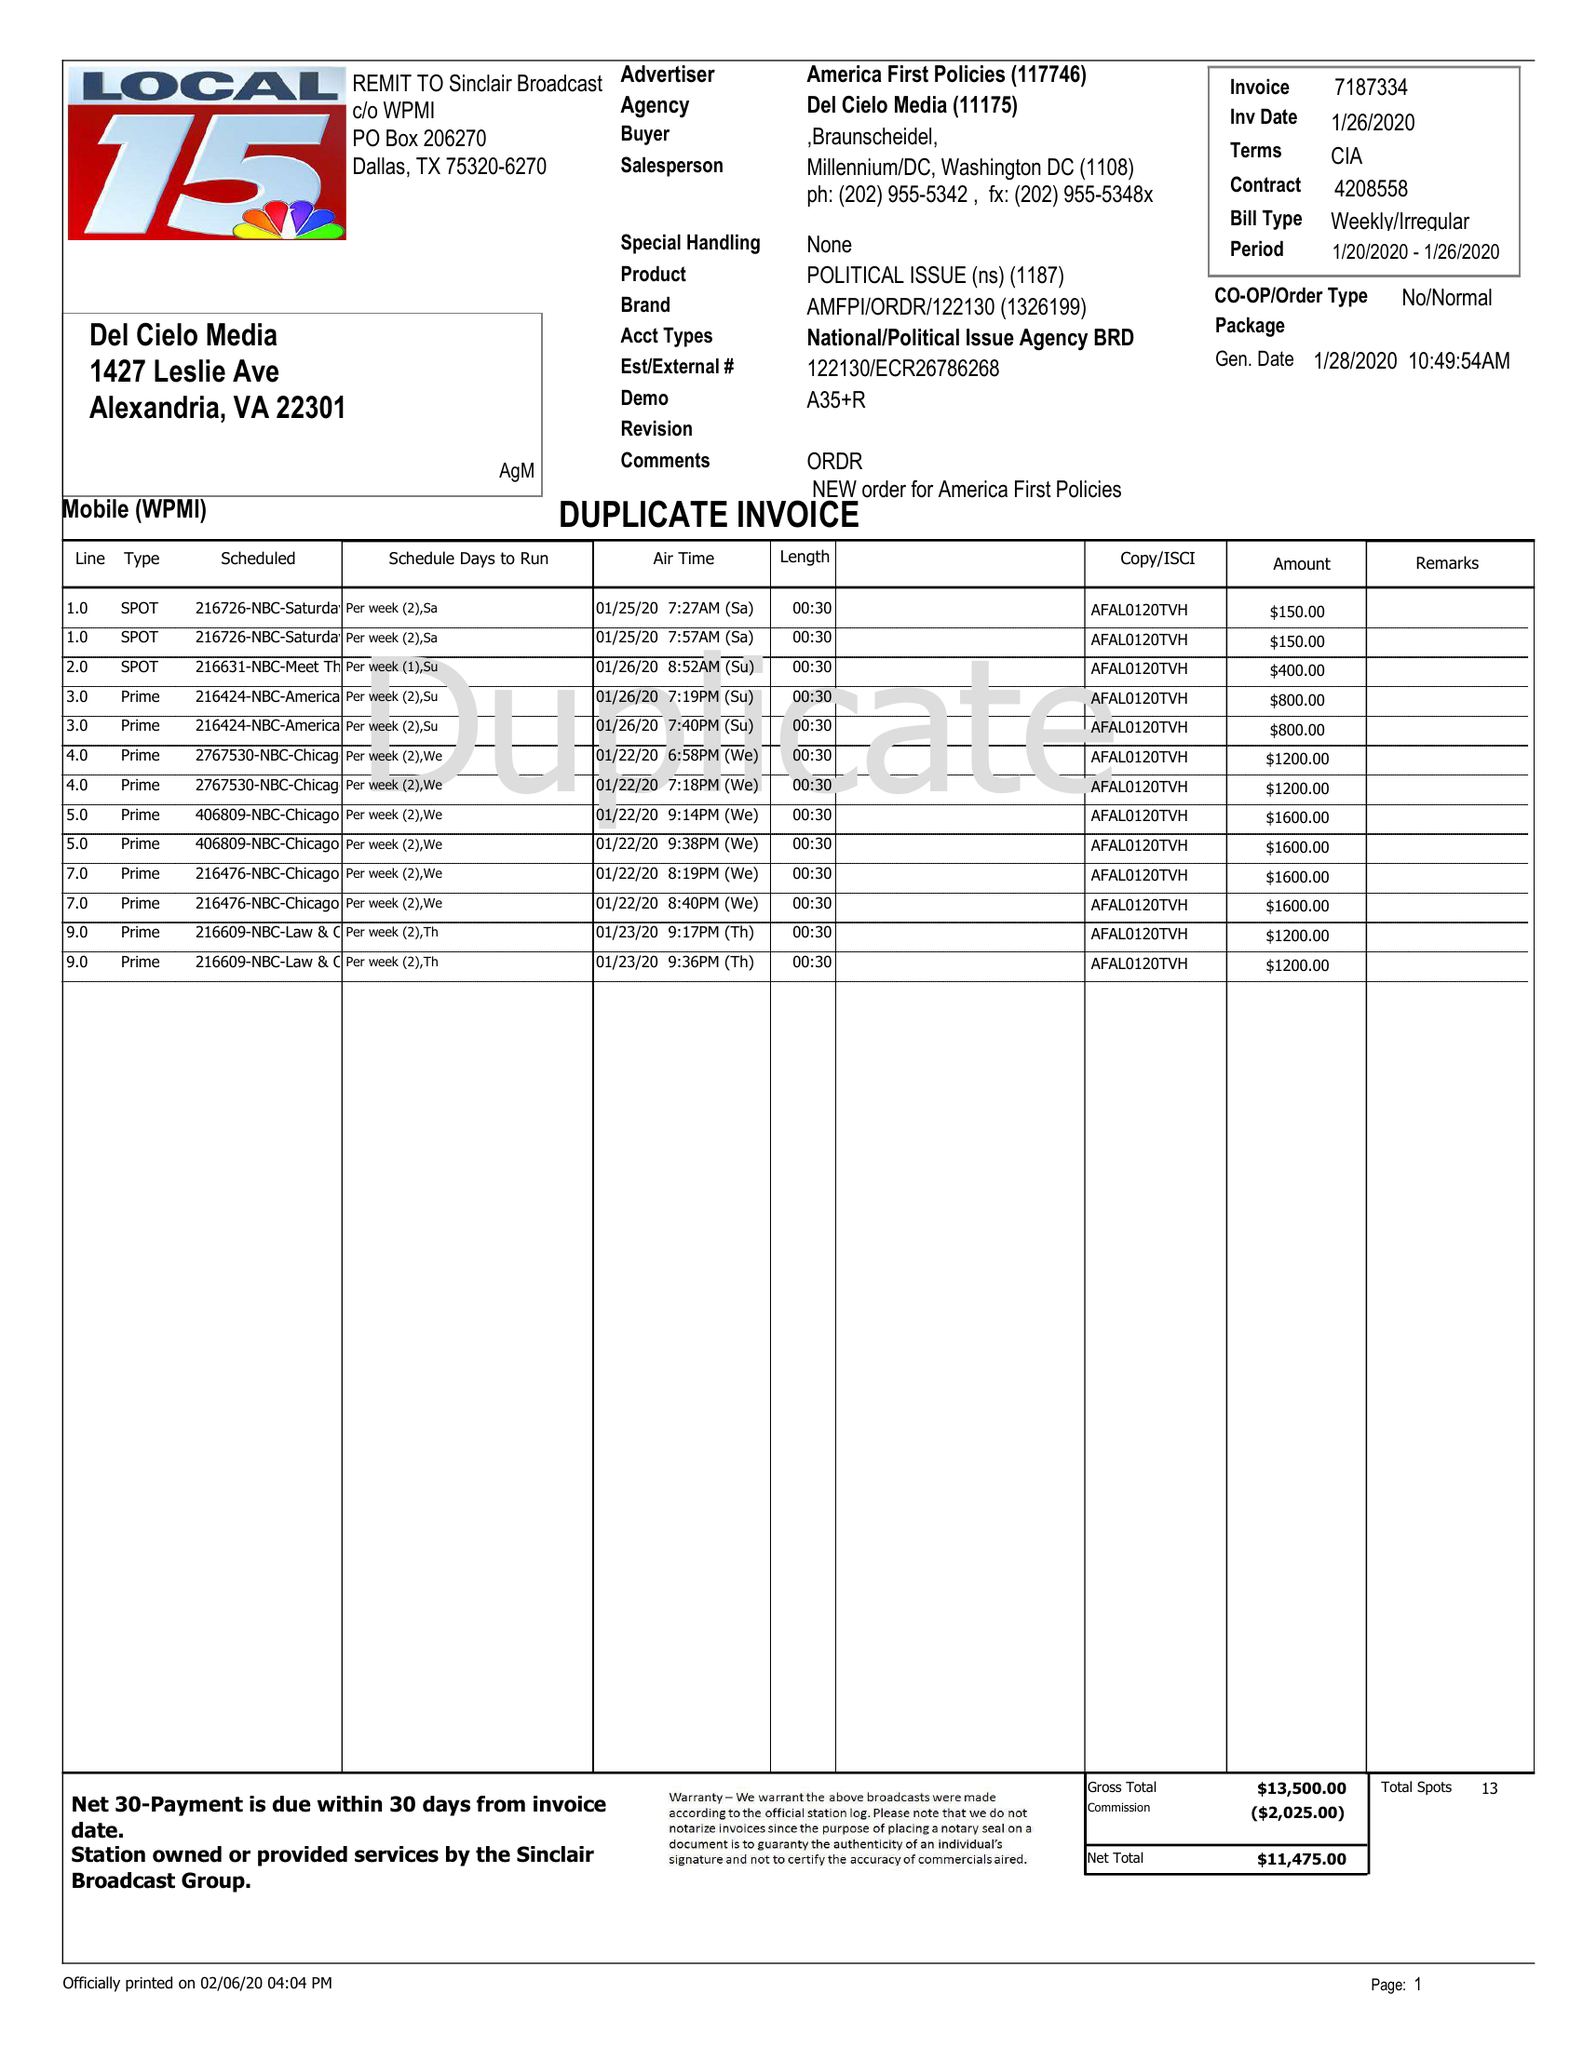What is the value for the flight_from?
Answer the question using a single word or phrase. 01/20/20 